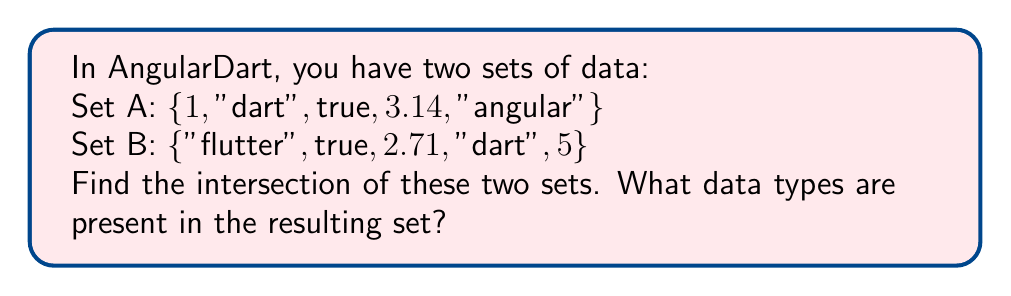Show me your answer to this math problem. To solve this problem, we need to follow these steps:

1. Identify the elements that are common to both sets:
   Set A: {1, "dart", true, 3.14, "angular"}
   Set B: {"flutter", true, 2.71, "dart", 5}
   
   Common elements: "dart" and true

2. Write the intersection of the two sets:
   $A \cap B = \{"dart", true\}$

3. Identify the data types of the elements in the intersection:
   - "dart" is a String
   - true is a bool (boolean)

In AngularDart, it's important to note that sets can contain elements of different data types. This is because Dart is an object-oriented language, and all data types inherit from the Object class. However, when working with sets in AngularDart, it's generally a good practice to use sets of a single data type for better type safety and easier manipulation.
Answer: The intersection of the two sets is $\{"dart", true\}$, containing elements of String and bool data types. 